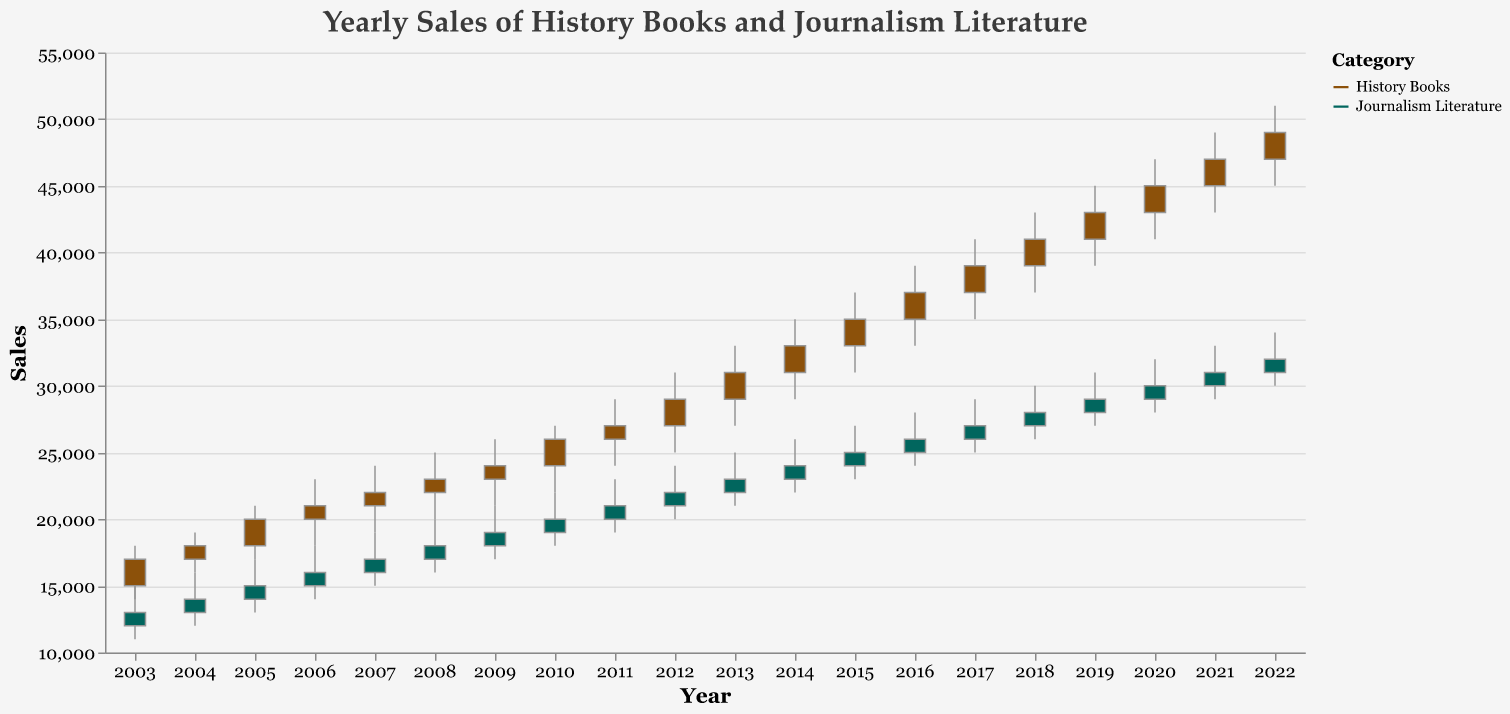What is the title of the figure? The title is located at the top of the figure and it is usually in a larger and bolder font compared to other texts. It reads: "Yearly Sales of History Books and Journalism Literature".
Answer: Yearly Sales of History Books and Journalism Literature What are the categories represented in the plot? The categories can be identified by the legend or color distinctions within the plot. The colors differentiate sales data of "History Books" and "Journalism Literature".
Answer: History Books and Journalism Literature In which year did History Books have the highest sales? To find this, look for the bar with the highest value for History Books in the sales axis. The year 2022 has the highest value at 51000.
Answer: 2022 What was the opening sales figure for Journalism Literature in 2017? Locate the bar for Journalism Literature in 2017 and refer to the open value which is indicated by the start of the bar. The opening sales figure in 2017 for Journalism Literature is 26000.
Answer: 26000 How much did the sales of History Books increase from the opening to closing in 2010? For 2010, look at the bar representing History Books. The opening sales were 24000 and the closing sales were 26000, calculate the difference: 26000 - 24000 = 2000.
Answer: 2000 Compare the closing sales of History Books and Journalism Literature in 2003. Review the closing values for both History Books and Journalism Literature in 2003. History Books closed at 17000 and Journalism Literature closed at 13000, comparing them shows History Books had higher sales.
Answer: History Books What were the highest and lowest sales figures for Journalism Literature in 2015? Identify the range of the bar representing Journalism Literature in 2015. The highest sales were 27000 and the lowest were 23000.
Answer: Highest: 27000, Lowest: 23000 Did the sales of Journalism Literature ever surpass those of History Books in any year? Evaluate the bars for each category year by year to see if Journalism Literature's values ever exceeded those of History Books. There is no year where Journalism Literature sales surpassed History Books.
Answer: No What was the average closing sales value for History Books between 2003 and 2007? Sum the closing sales for History Books from 2003 to 2007: 17000 + 18000 + 20000 + 21000 + 22000 = 98000, then divide by 5 (number of years): 98000 / 5 = 19600.
Answer: 19600 What is the trend in sales for History Books from 2003 to 2022? Observe the bars for History Books over the given years. The trend shows a steady increase in sales from 15000 in 2003 to 49000 in 2022.
Answer: Increasing 